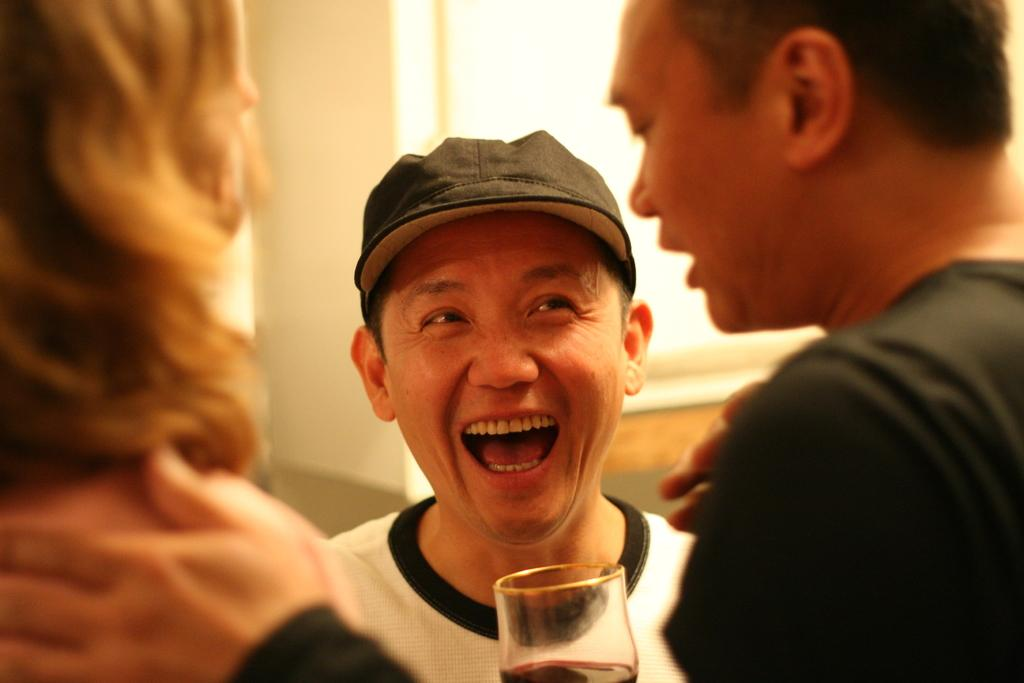What is the main subject of the image? The main subject of the image is people in the center. Can you describe any objects near the bottom of the image? There is a glass at the bottom side of the image. What can be seen in the background of the image? There is a window in the background area of the image. Can you tell me how many kittens are sitting on the window sill in the image? There are no kittens present in the image; only people, a glass, and a window are visible. 